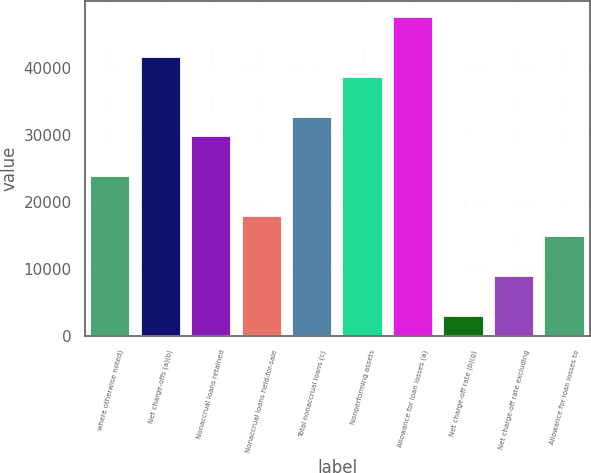<chart> <loc_0><loc_0><loc_500><loc_500><bar_chart><fcel>where otherwise noted)<fcel>Net charge-offs (a)(b)<fcel>Nonaccrual loans retained<fcel>Nonaccrual loans held-for-sale<fcel>Total nonaccrual loans (c)<fcel>Nonperforming assets<fcel>Allowance for loan losses (a)<fcel>Net charge-off rate (b)(g)<fcel>Net charge-off rate excluding<fcel>Allowance for loan losses to<nl><fcel>23799.7<fcel>41647.7<fcel>29749<fcel>17850.4<fcel>32723.7<fcel>38673<fcel>47597<fcel>2977.1<fcel>8926.42<fcel>14875.7<nl></chart> 